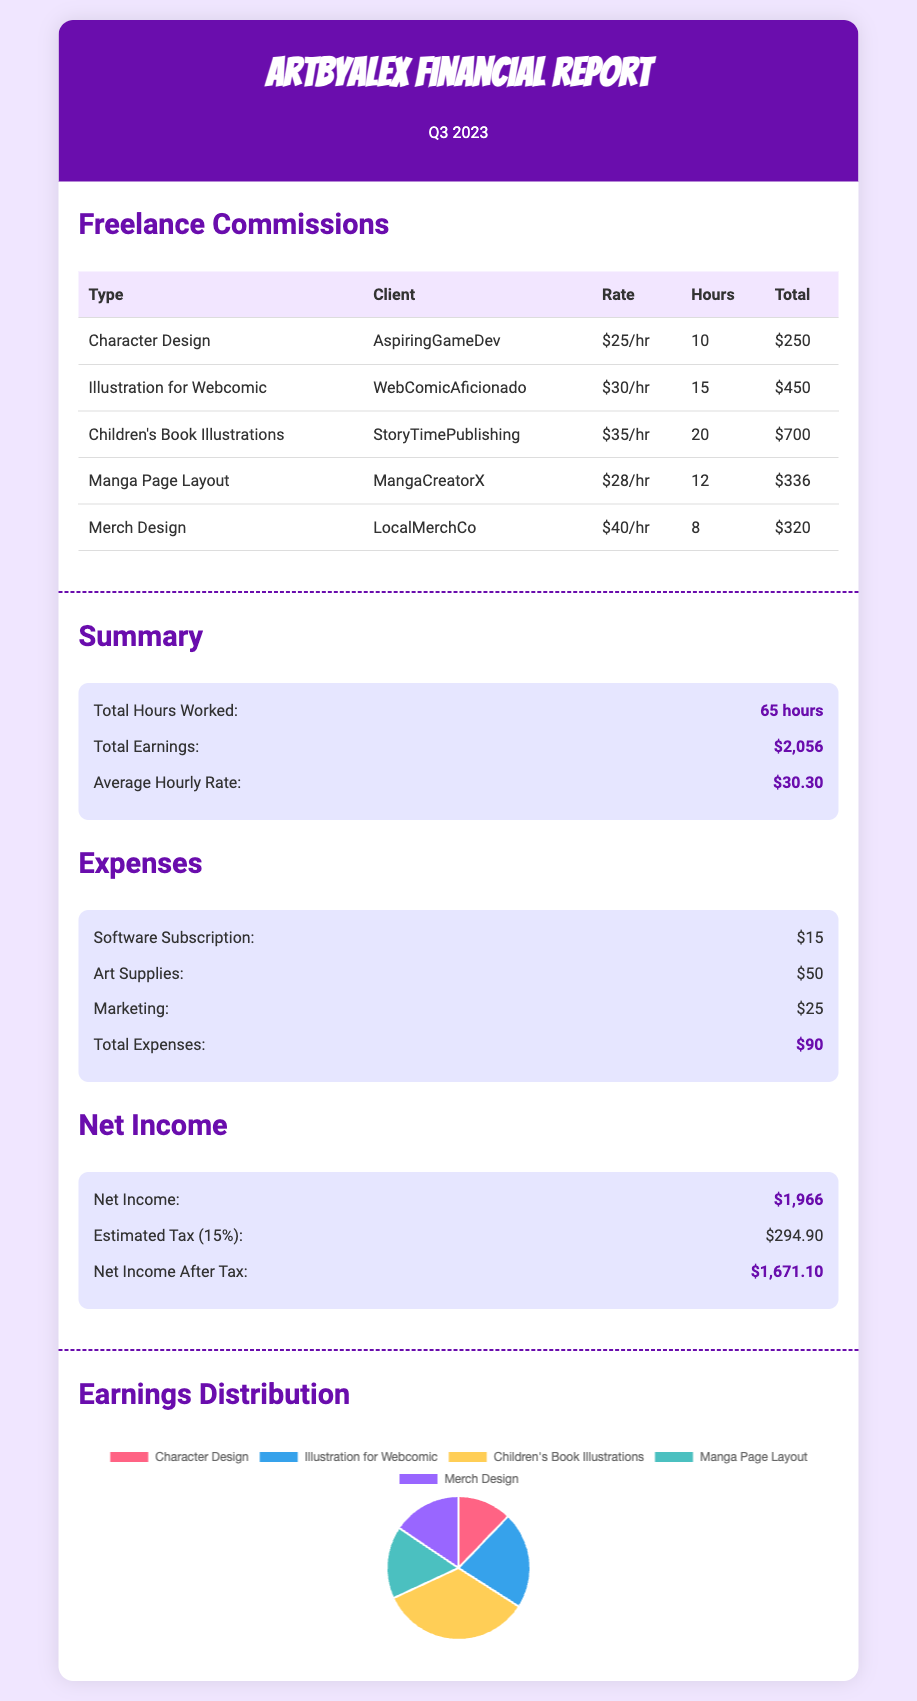what is the total earnings for the quarter? The total earnings are explicitly stated in the summary section of the financial report as $2,056.
Answer: $2,056 what was the average hourly rate? The document provides the average hourly rate in the summary section as $30.30.
Answer: $30.30 who was the client for the Children's Book Illustrations? The client for the Children's Book Illustrations is mentioned in the table as StoryTimePublishing.
Answer: StoryTimePublishing how many total hours were worked? The total hours worked are listed in the summary section as 65 hours.
Answer: 65 hours what is the total amount spent on marketing? The report includes the marketing expense as $25 under the expenses section.
Answer: $25 which type of commission earned the most? By reviewing the earnings distribution in the table, Children's Book Illustrations earned the highest at $700.
Answer: Children's Book Illustrations what is the total amount of expenses? The total expenses are summarized in the report as $90.
Answer: $90 what is the net income after tax? The net income after tax is provided in the net income section, which amounts to $1,671.10.
Answer: $1,671.10 how much were the expenses for art supplies? The document states that the expenses for art supplies were $50.
Answer: $50 